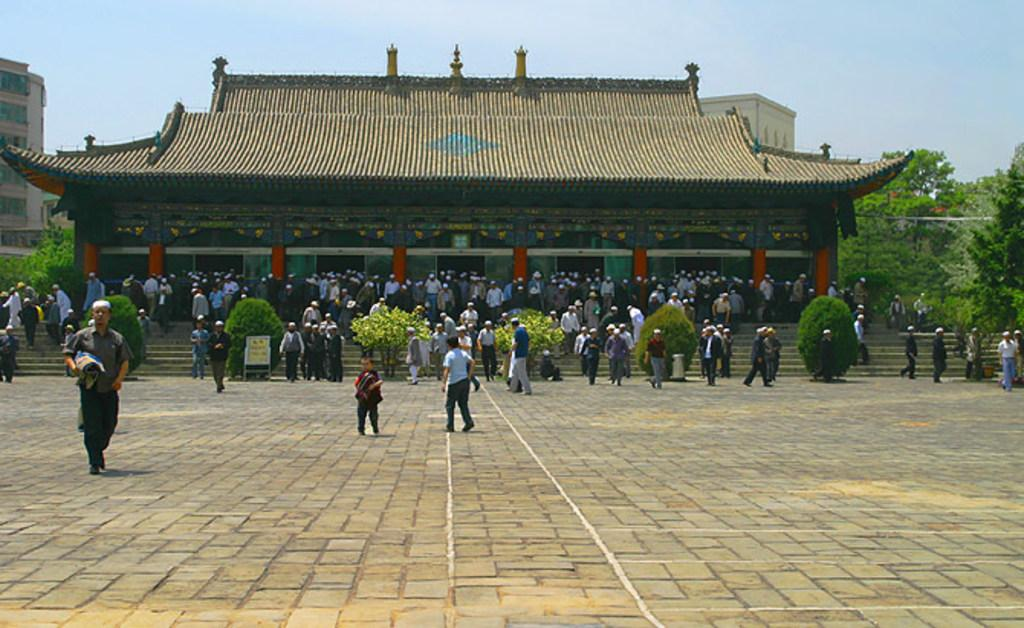Who or what can be seen in the image? There are people in the image. What structures are visible in the image? There are buildings in the image. What type of vegetation is present in the image? There are trees in the image. What is visible at the top of the image? The sky is visible at the top of the image. Where can the popcorn be found in the image? There is no popcorn present in the image. What order are the people and buildings arranged in the image? The arrangement of people and buildings cannot be determined from the image alone, as it does not provide information about their relative positions. 